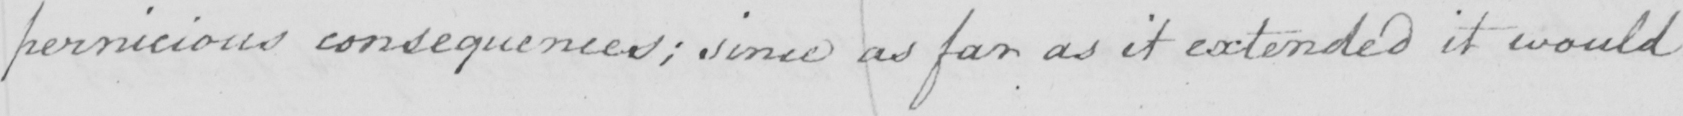What text is written in this handwritten line? pernicious consequences ; since as far as it extended it would 